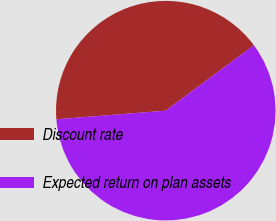Convert chart to OTSL. <chart><loc_0><loc_0><loc_500><loc_500><pie_chart><fcel>Discount rate<fcel>Expected return on plan assets<nl><fcel>41.09%<fcel>58.91%<nl></chart> 